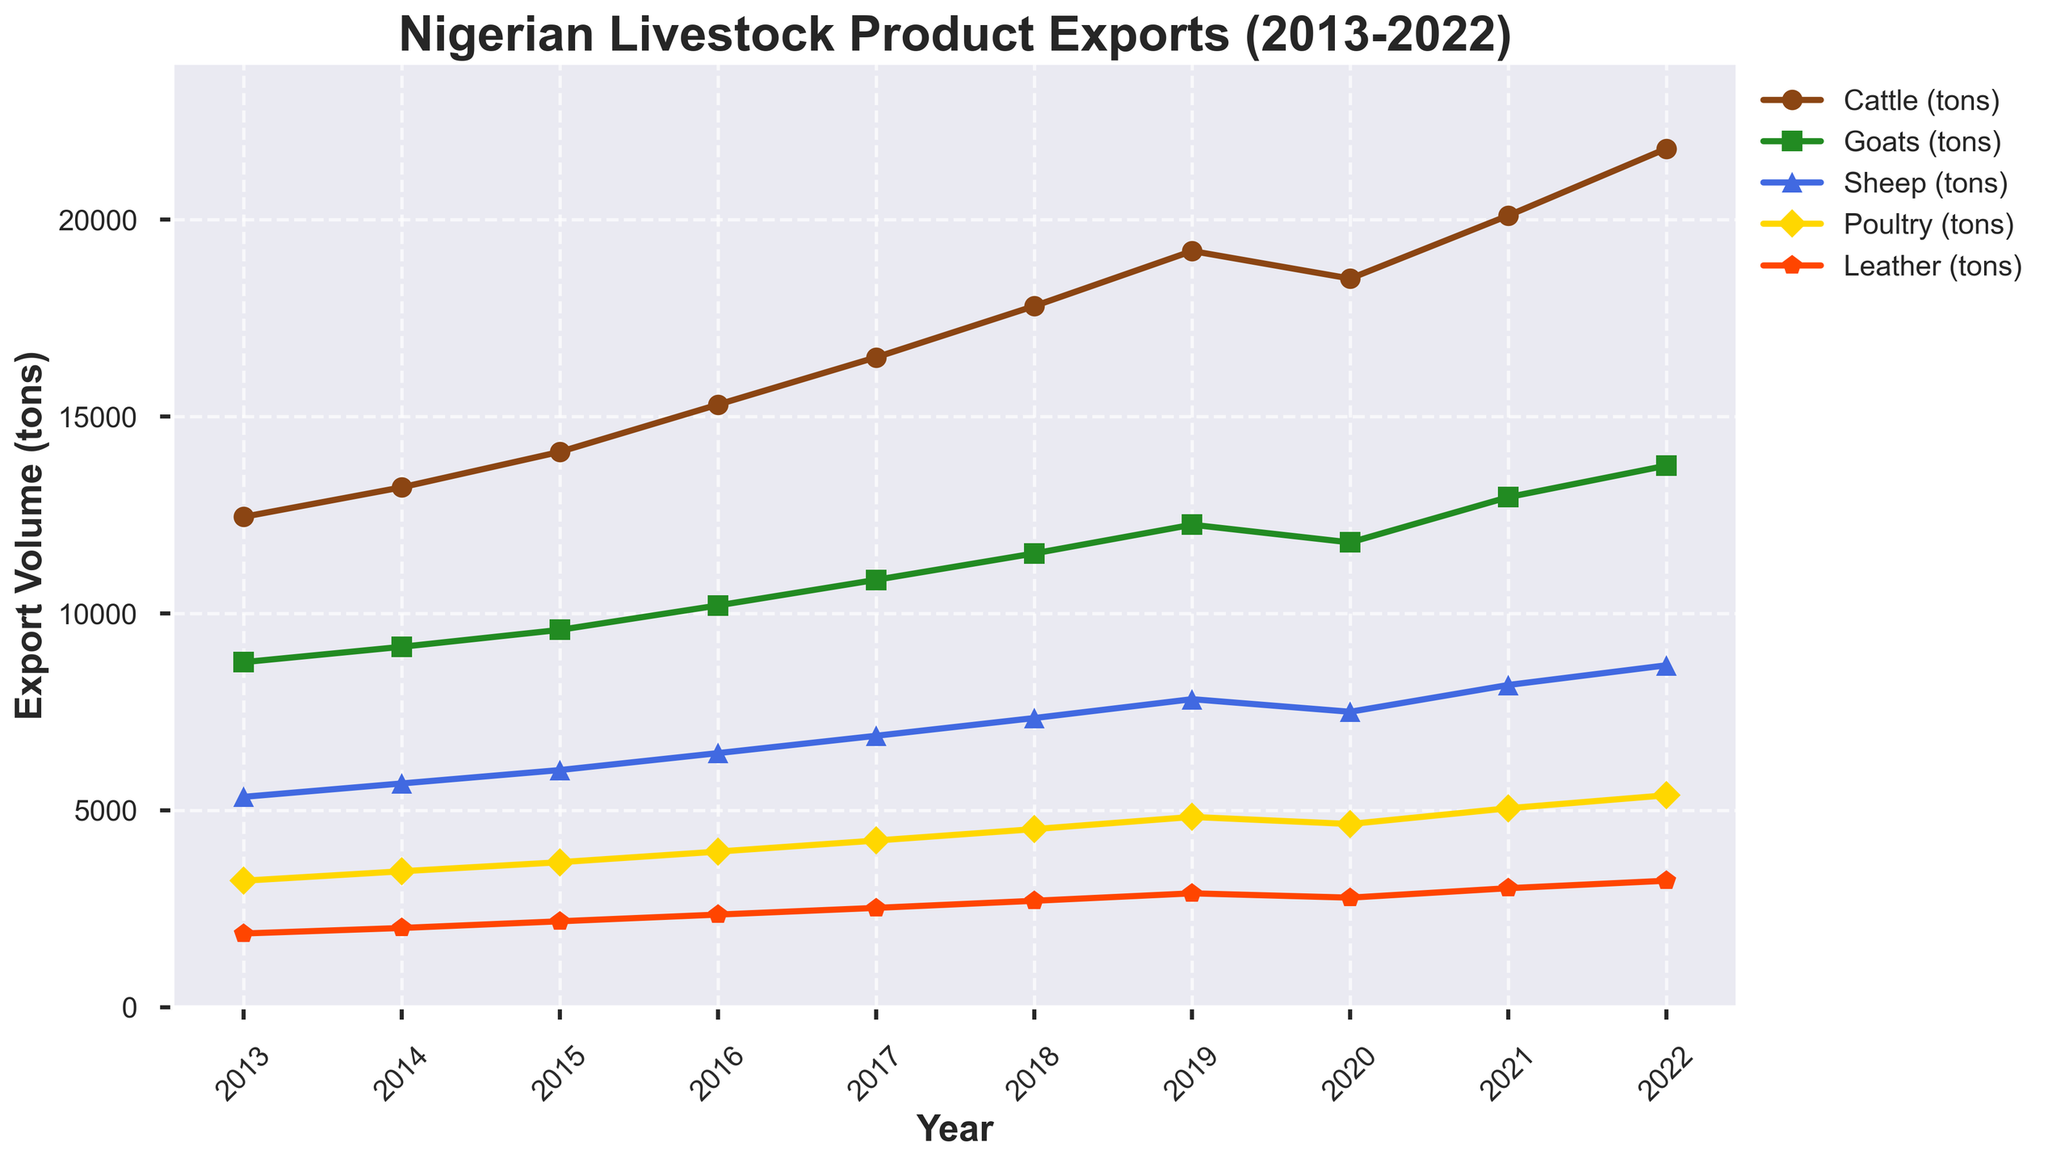What is the overall trend of Nigerian livestock product exports from 2013 to 2022? To determine the overall trend, observe the direction of the lines representing each type of livestock product over the entire period. All products show an increasing trend from 2013 to 2022, though there is a slight dip in 2020.
Answer: Increasing Which livestock product had the highest export volume in 2022? Look at the endpoint (2022) of each line and find the highest point. Cattle had the highest export volume in 2022.
Answer: Cattle How did the export volume of poultry change from 2019 to 2020? Compare the position of the poultry line at 2019 and 2020. The export volume of poultry decreased from 4830 tons in 2019 to 4650 tons in 2020.
Answer: Decreased Which livestock product showed the most significant growth in export volume from 2013 to 2022? Compare the difference in export volumes for each livestock product between 2013 and 2022. Cattle exhibited the most significant growth, from 12450 tons in 2013 to 21800 tons in 2022.
Answer: Cattle By how much did the export volume of leather increase from 2013 to 2015? Calculate the difference between the leather export volumes in 2013 and 2015. In 2013, it was 1870 tons, and in 2015, it was 2180 tons. So, the increase is 2180 - 1870 = 310 tons.
Answer: 310 tons What was the average annual export volume of goats between 2013 and 2022? Sum the export volumes of goats from 2013 to 2022 and divide by the number of years. The total is 8760 + 9150 + 9580 + 10200 + 10850 + 11520 + 12250 + 11800 + 12950 + 13750 = 110310 tons, and the average is 110310 / 10 = 11031 tons.
Answer: 11031 tons Compare the export volumes of sheep and goats in 2016. Which was higher and by how much? Check the export volumes for sheep and goats in 2016. Goats had 10200 tons, and sheep had 6450 tons. Thus, goats had a higher volume by 10200 - 6450 = 3750 tons.
Answer: Goats by 3750 tons Between poultry and leather, which one had a higher minimum export volume over the decade? Identify the smallest value for both poultry and leather over the ten years. The minimum for poultry is 3210 tons (2013), and for leather, it is 1870 tons (2013). Poultry's minimum export volume is higher.
Answer: Poultry What is the total cumulative export volume of cattle from 2013 to 2022? Add the annual export volumes of cattle from 2013 to 2022. The sum is 12450 + 13200 + 14100 + 15300 + 16500 + 17800 + 19200 + 18500 + 20100 + 21800 = 168950 tons.
Answer: 168950 tons 